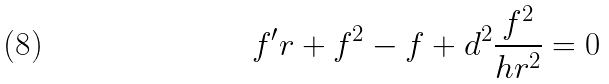<formula> <loc_0><loc_0><loc_500><loc_500>f ^ { \prime } r + f ^ { 2 } - f + d ^ { 2 } \frac { f ^ { 2 } } { h r ^ { 2 } } = 0</formula> 